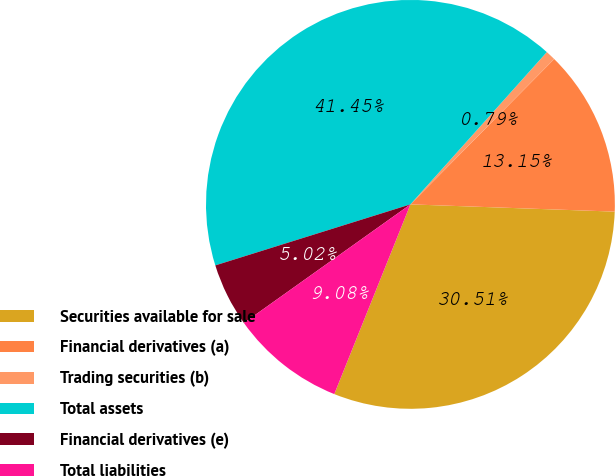<chart> <loc_0><loc_0><loc_500><loc_500><pie_chart><fcel>Securities available for sale<fcel>Financial derivatives (a)<fcel>Trading securities (b)<fcel>Total assets<fcel>Financial derivatives (e)<fcel>Total liabilities<nl><fcel>30.51%<fcel>13.15%<fcel>0.79%<fcel>41.45%<fcel>5.02%<fcel>9.08%<nl></chart> 